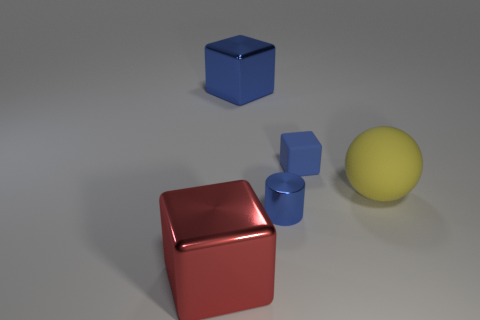Subtract all big metal cubes. How many cubes are left? 1 Subtract all blocks. How many objects are left? 2 Subtract all cyan blocks. Subtract all brown balls. How many blocks are left? 3 Subtract all gray cubes. How many cyan cylinders are left? 0 Subtract all yellow cylinders. Subtract all big blue metal cubes. How many objects are left? 4 Add 4 big objects. How many big objects are left? 7 Add 3 blue matte cubes. How many blue matte cubes exist? 4 Add 1 blue cubes. How many objects exist? 6 Subtract all blue blocks. How many blocks are left? 1 Subtract 0 purple balls. How many objects are left? 5 